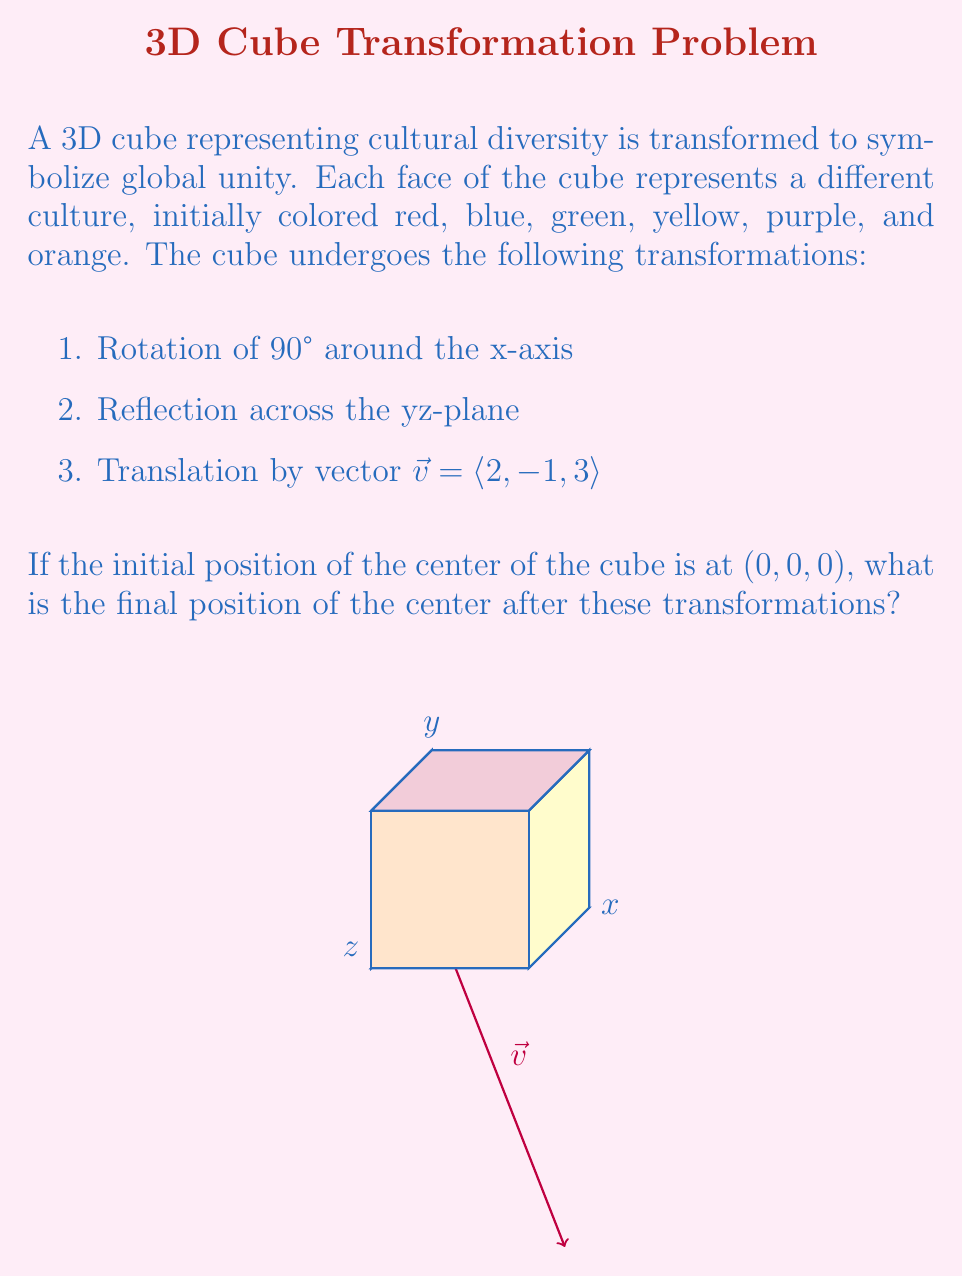What is the answer to this math problem? Let's break down the transformations step by step:

1. Rotation of 90° around the x-axis:
   This doesn't affect the x-coordinate. It swaps y and z coordinates and negates the new z.
   $(0, 0, 0) \rightarrow (0, 0, 0)$ (center remains unchanged)

2. Reflection across the yz-plane:
   This negates the x-coordinate.
   $(0, 0, 0) \rightarrow (0, 0, 0)$ (center still unchanged)

3. Translation by vector $\vec{v} = \langle 2, -1, 3 \rangle$:
   This adds the components of $\vec{v}$ to the current position.
   $(0, 0, 0) + \langle 2, -1, 3 \rangle = (2, -1, 3)$

Therefore, the final position of the center of the cube is $(2, -1, 3)$.

This transformation can be seen as a metaphor for how diverse cultures (represented by the different colored faces) can maintain their uniqueness while coming together in a unified global position (the final coordinates), reflecting the perspective of an international student observing global cultural dynamics.
Answer: $(2, -1, 3)$ 